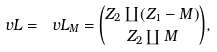Convert formula to latex. <formula><loc_0><loc_0><loc_500><loc_500>\ v L = \ v L _ { M } = \binom { Z _ { 2 } \coprod ( Z _ { 1 } - M ) } { Z _ { 2 } \coprod M } ,</formula> 